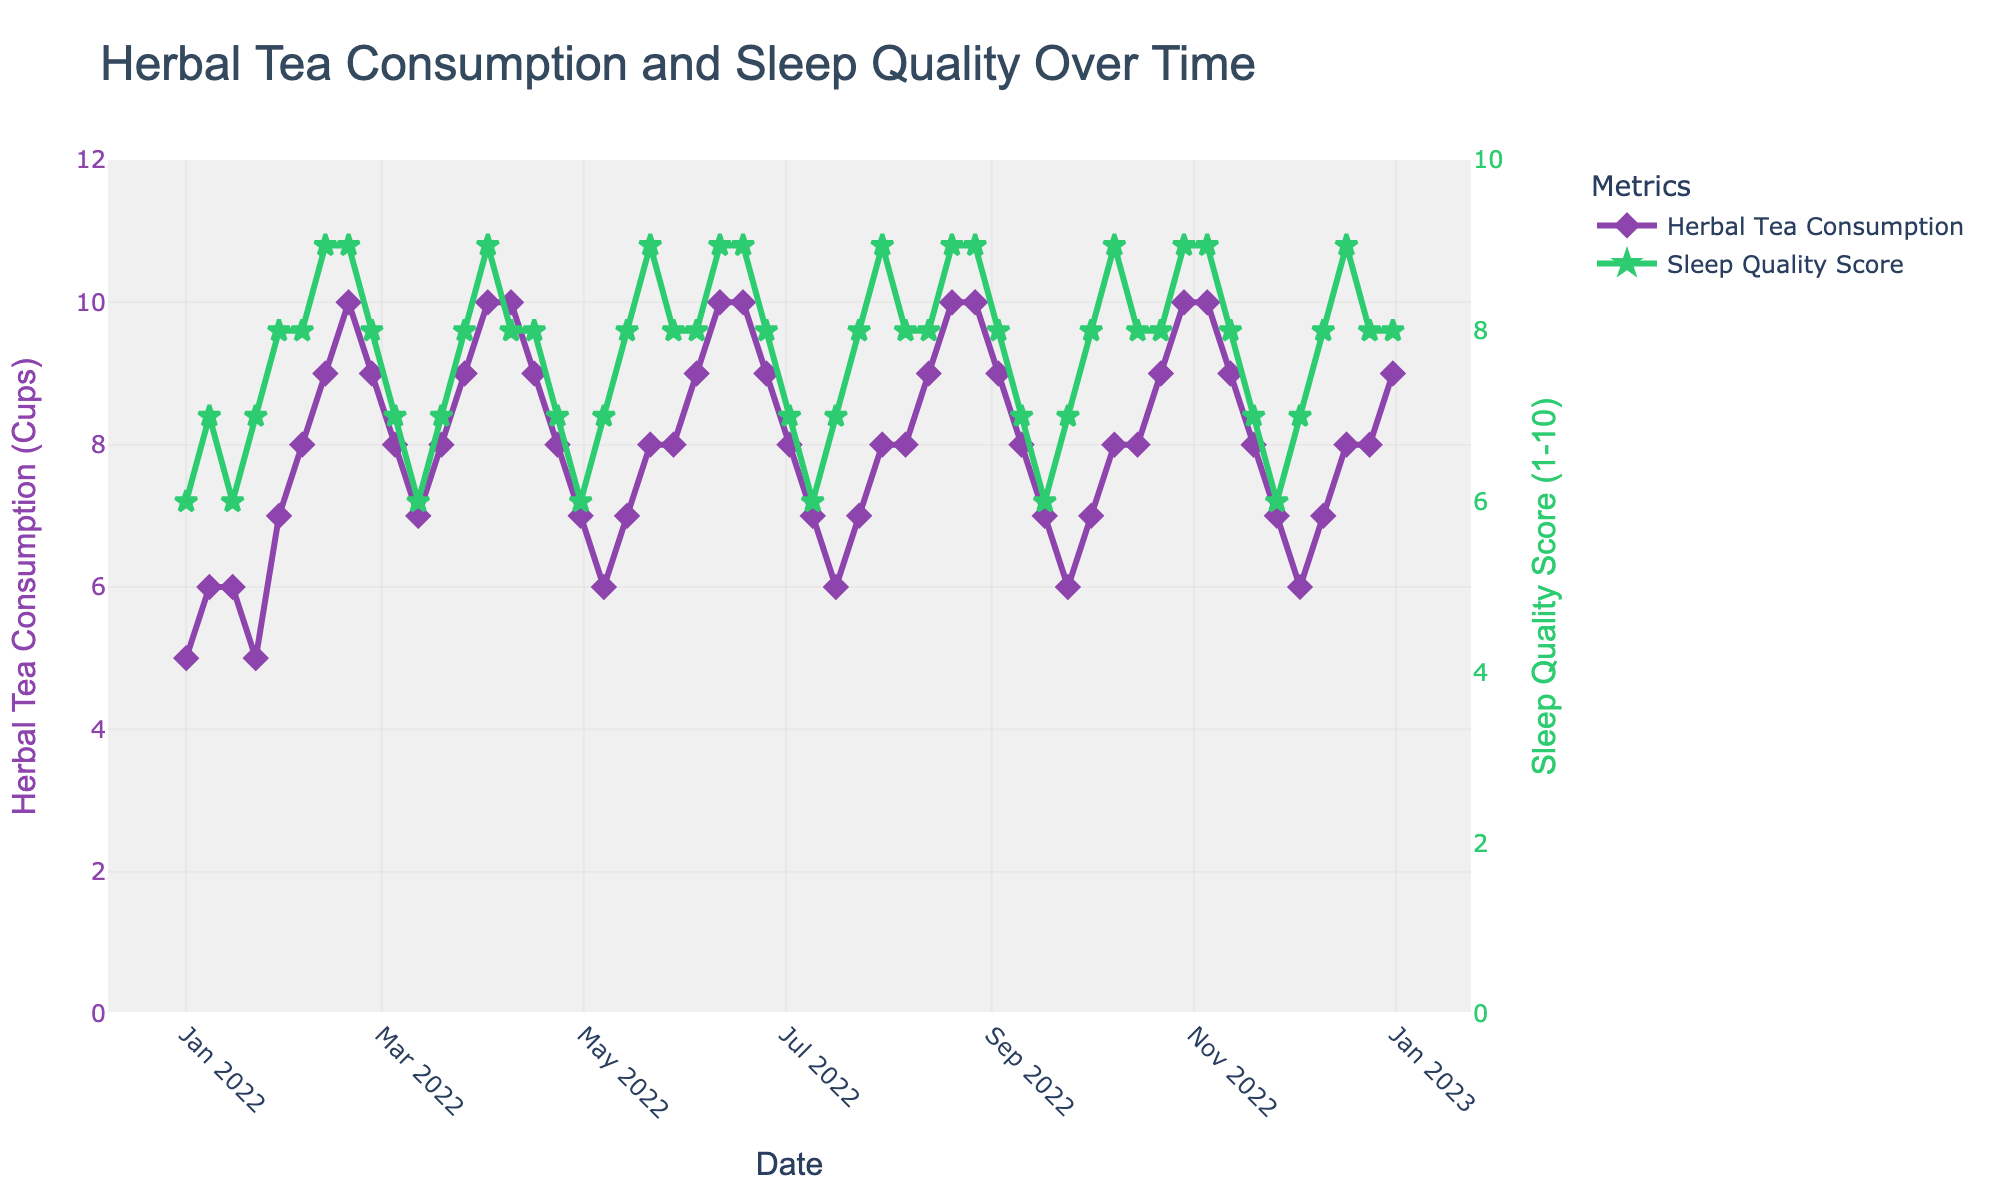What is the trend in herbal tea consumption over the year? By observing the plot, the general trend line for herbal tea consumption shows fluctuations but trends upward overall. It starts lower at the beginning of the year, increases, peaking around mid-year, and then fluctuates with periodic increases and decreases throughout the rest of the year.
Answer: Upward overall How does sleep quality change as herbal tea consumption increases? The plot indicates that as the number of cups of herbal tea increases, the sleep quality score also tends to increase. Specifically, sleep quality improves with higher herbal tea consumption, and both metrics show peaks around mid-year.
Answer: Improves What is the maximum sleep quality score, and when does it occur? The plot shows that the maximum sleep quality score is 9. By matching this score with the date on the x-axis, we see it occurs on multiple dates, including February 12, February 19, April 2, etc.
Answer: 9, multiple dates including February 12 Which month had the highest average herbal tea consumption? To find the month with the highest average herbal tea consumption, we observe the plot for peaks. The month of April shows consistently high consumption rates, particularly around April 2 and April 9, with values reaching 10 cups.
Answer: April Is there any week with stable (no increase or decrease) values of sleep quality score? To identify stable values, we look for weeks where the sleep quality score remains the same. Observing the plot, the scores were stable on weeks like February 12 and 19, both at 9, and November 5 and 12, both at 9.
Answer: Yes, there are weeks like February 12 and 19 How do herbal tea consumption and sleep quality scores compare at the beginning and end of the year? At the beginning (January 1), herbal tea consumption is 5 cups, and sleep quality score is 6. At the end (December 31), herbal tea consumption is 9 cups, and the sleep quality score is 8. This shows an increase in both metrics over the year.
Answer: Increased for both metrics On average, how many cups of herbal tea were consumed per week? To find the average weekly consumption, sum the weekly values of herbal tea consumption and divide by the number of weeks (52). The total herbal tea consumption for the year is the sum of all data points in the "Herbal_Tea_Consumption (Cups)" column.
Answer: Approximately 8 cups per week During which period is the sleep quality score at its lowest, and how does herbal tea consumption compare during this period? The sleep quality score is at its lowest (6) several times, such as January 15, March 12, and November 26. Comparing these times, herbal tea consumption ranges from 5 to 7 cups, showing variability.
Answer: Several instances with varying consumption between 5 to 7 cups 